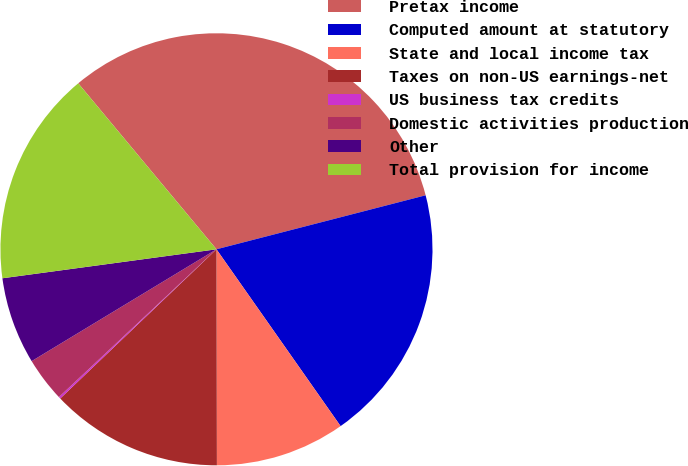Convert chart to OTSL. <chart><loc_0><loc_0><loc_500><loc_500><pie_chart><fcel>Pretax income<fcel>Computed amount at statutory<fcel>State and local income tax<fcel>Taxes on non-US earnings-net<fcel>US business tax credits<fcel>Domestic activities production<fcel>Other<fcel>Total provision for income<nl><fcel>32.03%<fcel>19.28%<fcel>9.71%<fcel>12.9%<fcel>0.14%<fcel>3.33%<fcel>6.52%<fcel>16.09%<nl></chart> 